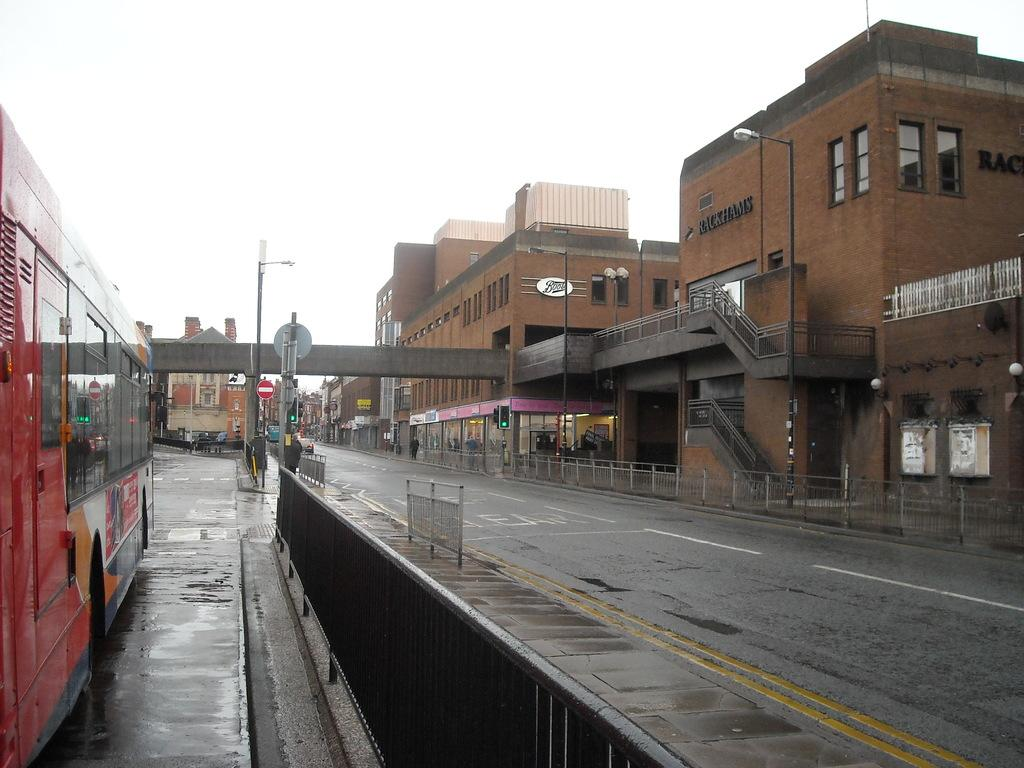<image>
Render a clear and concise summary of the photo. a quiet street in front of the building called Rackhams 